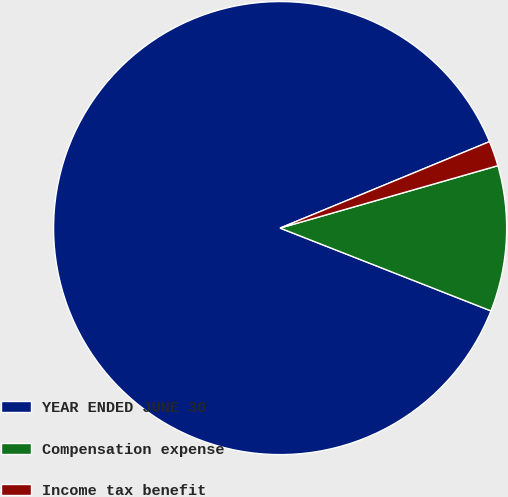Convert chart. <chart><loc_0><loc_0><loc_500><loc_500><pie_chart><fcel>YEAR ENDED JUNE 30<fcel>Compensation expense<fcel>Income tax benefit<nl><fcel>87.81%<fcel>10.4%<fcel>1.79%<nl></chart> 